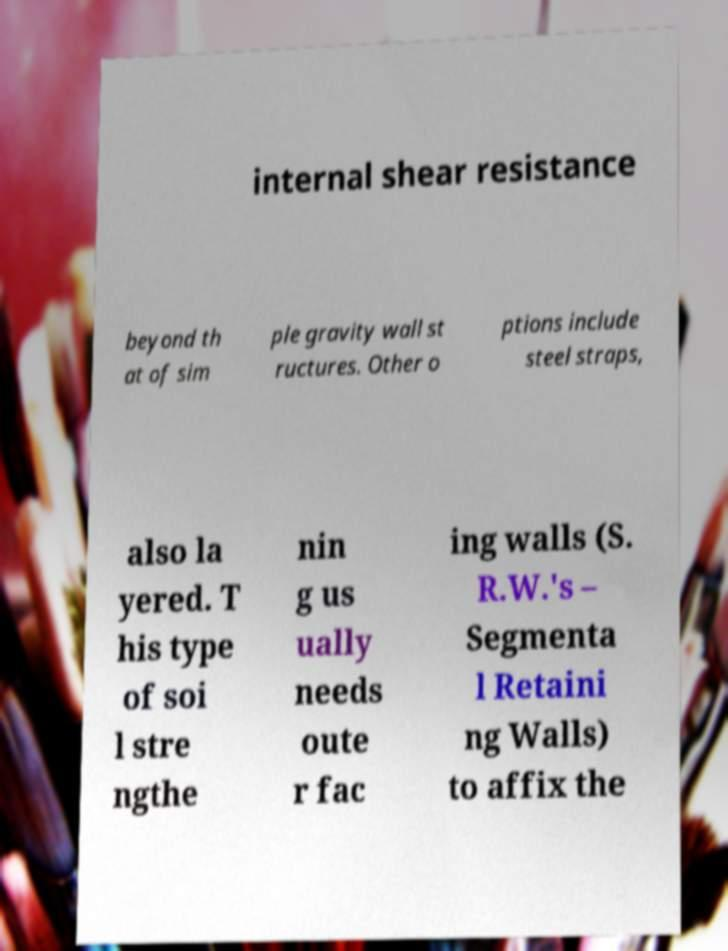For documentation purposes, I need the text within this image transcribed. Could you provide that? internal shear resistance beyond th at of sim ple gravity wall st ructures. Other o ptions include steel straps, also la yered. T his type of soi l stre ngthe nin g us ually needs oute r fac ing walls (S. R.W.'s – Segmenta l Retaini ng Walls) to affix the 